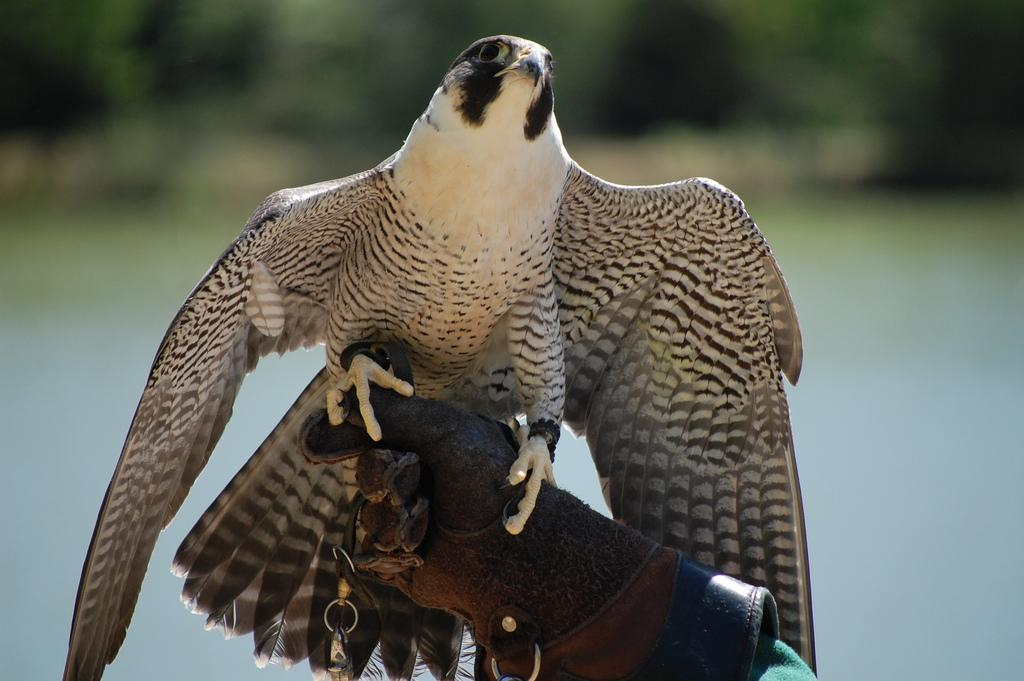What animal can be seen in the picture? There is an eagle in the picture. What is the eagle doing in the picture? The eagle is standing on a person's hand. What is the person wearing on their hands? The person is wearing gloves. What color is the person's t-shirt in the picture? The person is wearing a green t-shirt. How would you describe the background of the picture? The background image is blurry. Is the person in the picture stuck in quicksand? There is no indication of quicksand in the image, and the person is not shown to be stuck. What time of day is it in the picture? The time of day is not mentioned in the image, so it cannot be determined from the picture. 